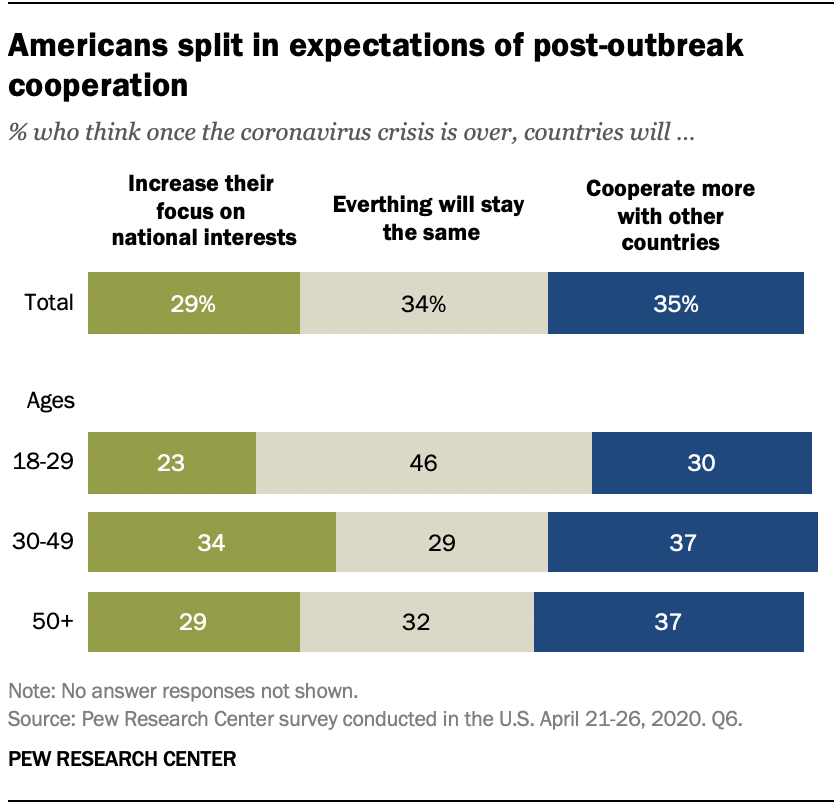Identify some key points in this picture. The sum of the highest value of green bars and the median value of green bars is 63. The task is to identify the missing value in the sequence of numbers 29, 23, _, 29? 34, where the missing value is represented by an underscore symbol. 